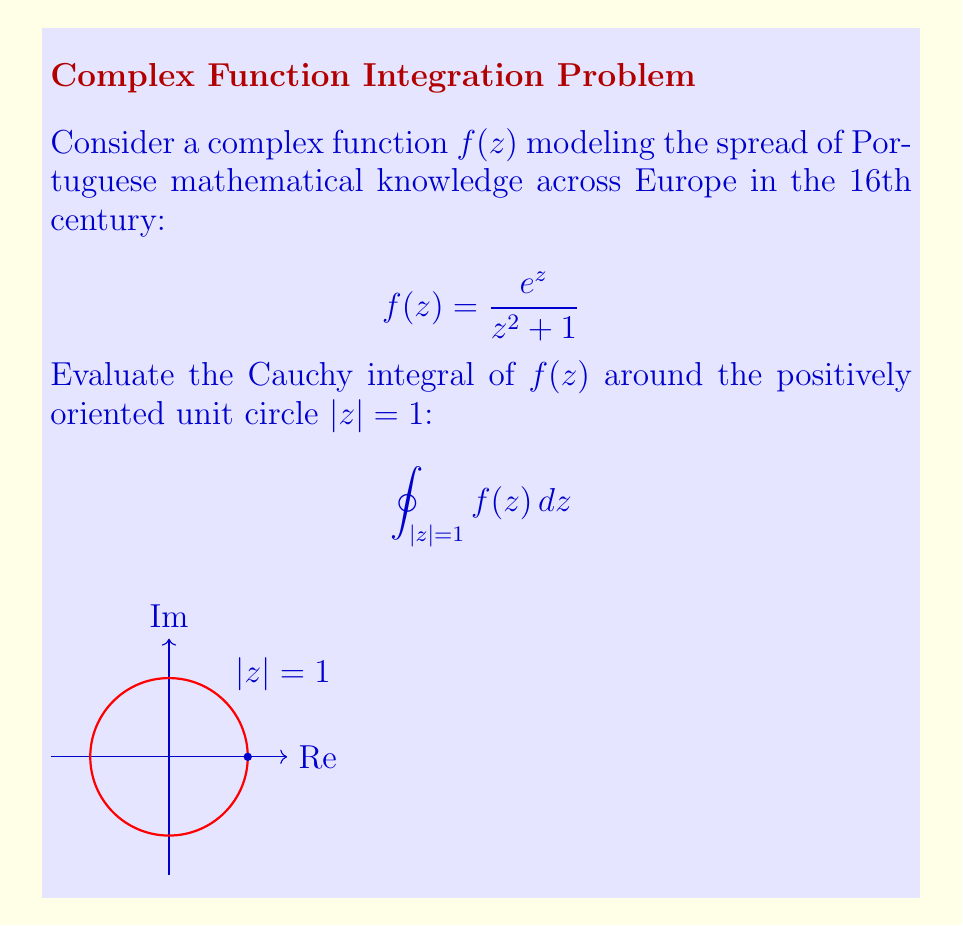Help me with this question. To evaluate this Cauchy integral, we'll follow these steps:

1) First, we need to identify the singularities of $f(z)$ inside the unit circle. The denominator $z^2 + 1$ has roots at $z = \pm i$, but only $z = i$ lies inside the unit circle.

2) We can use the Residue Theorem, which states:

   $$\oint_{C} f(z) dz = 2\pi i \sum \text{Res}(f, a_k)$$

   where $a_k$ are the singularities inside the contour C.

3) To find the residue at $z = i$, we use the formula for a simple pole:

   $$\text{Res}(f, i) = \lim_{z \to i} (z-i)f(z) = \lim_{z \to i} \frac{(z-i)e^z}{z^2 + 1}$$

4) Apply L'Hôpital's rule:

   $$\text{Res}(f, i) = \lim_{z \to i} \frac{e^z + (z-i)e^z}{2z} = \frac{e^i}{2i}$$

5) Now we can apply the Residue Theorem:

   $$\oint_{|z|=1} f(z) dz = 2\pi i \cdot \frac{e^i}{2i} = \pi e^i$$

6) We can express this in terms of real and imaginary parts:

   $$\pi e^i = \pi (\cos 1 + i \sin 1)$$

Thus, the value of the Cauchy integral is $\pi (\cos 1 + i \sin 1)$.
Answer: $\pi (\cos 1 + i \sin 1)$ 